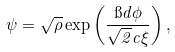Convert formula to latex. <formula><loc_0><loc_0><loc_500><loc_500>\psi = \sqrt { \rho } \exp \left ( \frac { \i d \phi } { \sqrt { 2 } c \xi } \right ) ,</formula> 